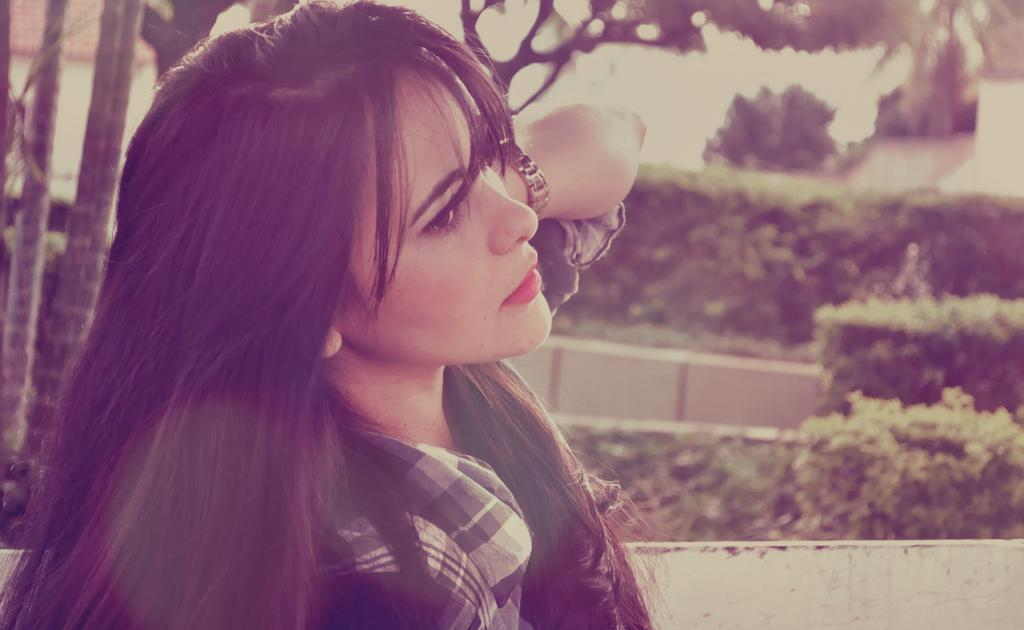Who is present in the image? There is a woman in the image. What can be seen in the background of the image? There are trees and plants in the background of the image. Can you describe the quality of the image? The top part of the image is slightly blurry. What type of blood is visible on the woman's shirt in the image? There is no blood visible on the woman's shirt in the image. What kind of cabbage is growing in the background of the image? There is no cabbage present in the image; it features trees and plants in the background. Can you spot a tiger hiding in the trees in the background of the image? There is no tiger present in the image; it only features trees and plants in the background. 